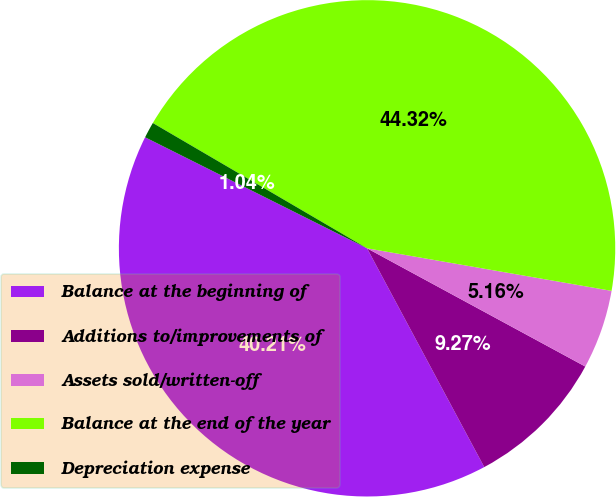<chart> <loc_0><loc_0><loc_500><loc_500><pie_chart><fcel>Balance at the beginning of<fcel>Additions to/improvements of<fcel>Assets sold/written-off<fcel>Balance at the end of the year<fcel>Depreciation expense<nl><fcel>40.21%<fcel>9.27%<fcel>5.16%<fcel>44.32%<fcel>1.04%<nl></chart> 